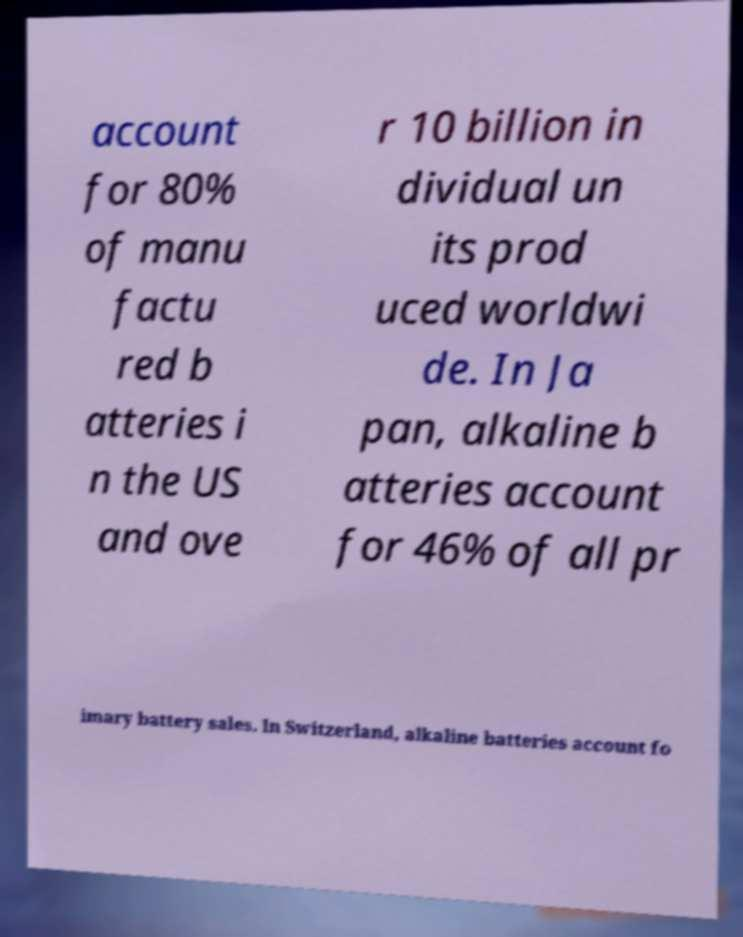There's text embedded in this image that I need extracted. Can you transcribe it verbatim? account for 80% of manu factu red b atteries i n the US and ove r 10 billion in dividual un its prod uced worldwi de. In Ja pan, alkaline b atteries account for 46% of all pr imary battery sales. In Switzerland, alkaline batteries account fo 